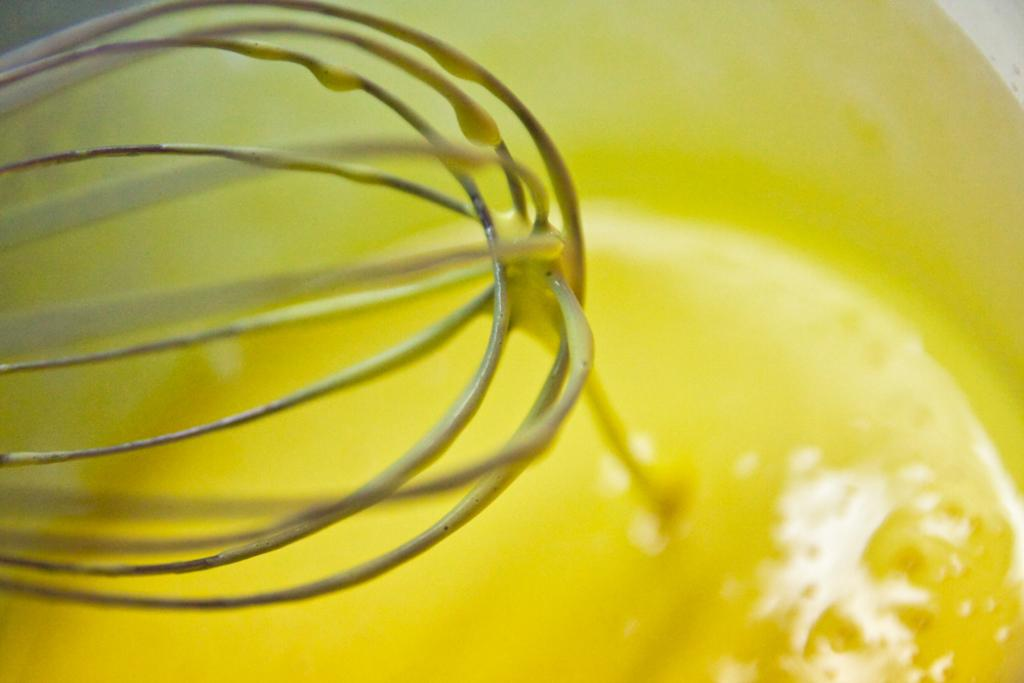What is in the image that holds a substance? There is a container in the image that holds a liquid. What type of substance is inside the container? The liquid inside the container is yellow in color. What material is the object in the image made of? There is a metal object in the image. How many leaves can be seen on the metal object in the image? There are no leaves present in the image; it only features a container with a yellow liquid and a metal object. 